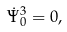<formula> <loc_0><loc_0><loc_500><loc_500>\dot { \Psi } _ { 0 } ^ { 3 } = 0 ,</formula> 